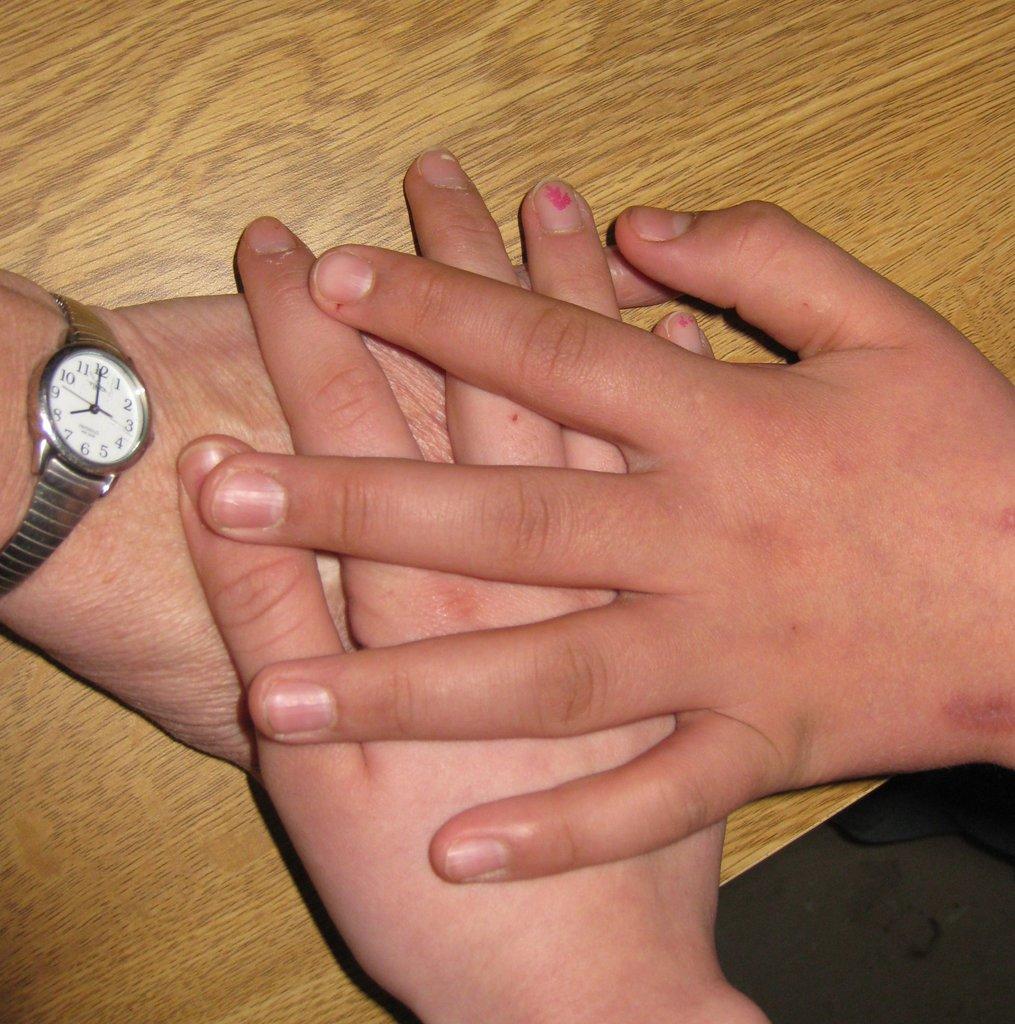What number is the minute hand pointing to?
Provide a short and direct response. 12. What is the hour?
Keep it short and to the point. 8:00. 